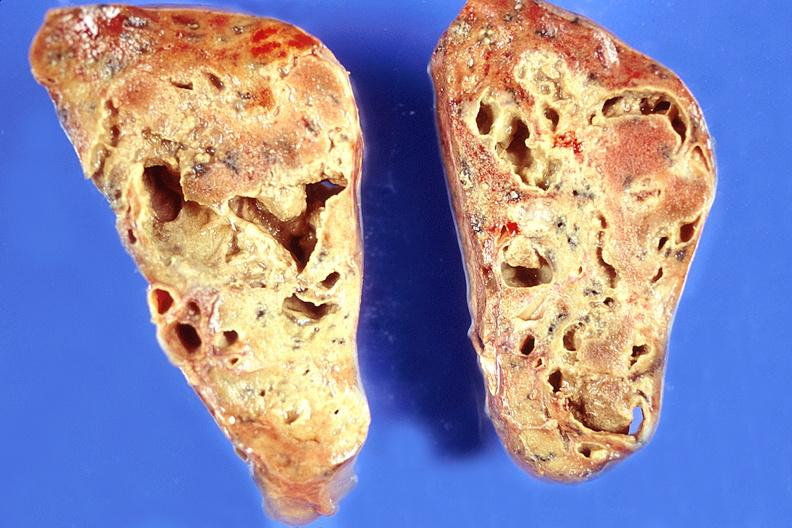where is this?
Answer the question using a single word or phrase. Lung 